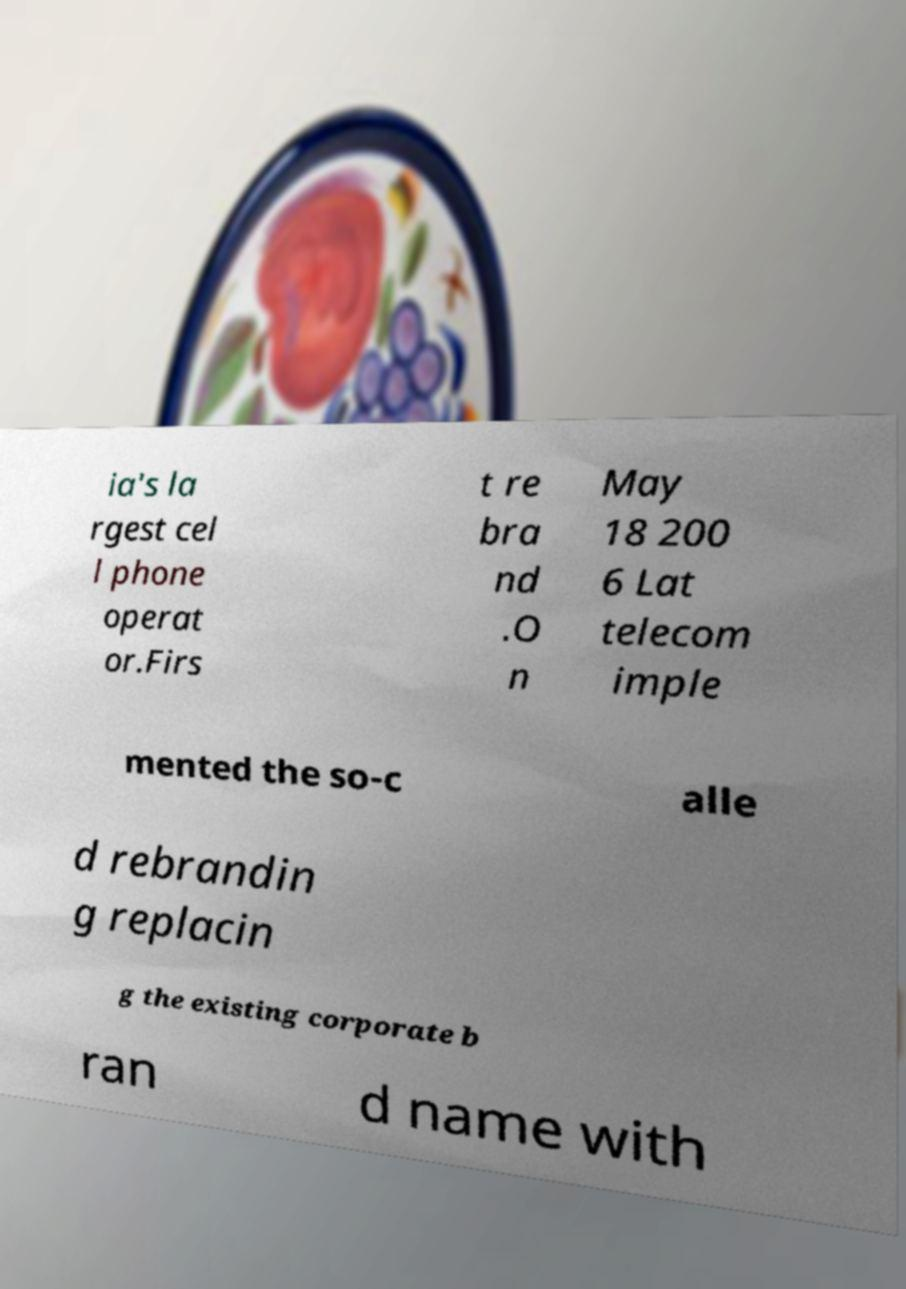Please identify and transcribe the text found in this image. ia's la rgest cel l phone operat or.Firs t re bra nd .O n May 18 200 6 Lat telecom imple mented the so-c alle d rebrandin g replacin g the existing corporate b ran d name with 